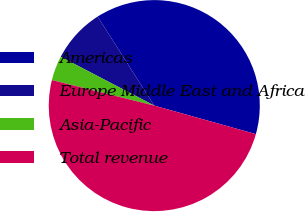Convert chart to OTSL. <chart><loc_0><loc_0><loc_500><loc_500><pie_chart><fcel>Americas<fcel>Europe Middle East and Africa<fcel>Asia-Pacific<fcel>Total revenue<nl><fcel>38.37%<fcel>8.33%<fcel>3.76%<fcel>49.53%<nl></chart> 